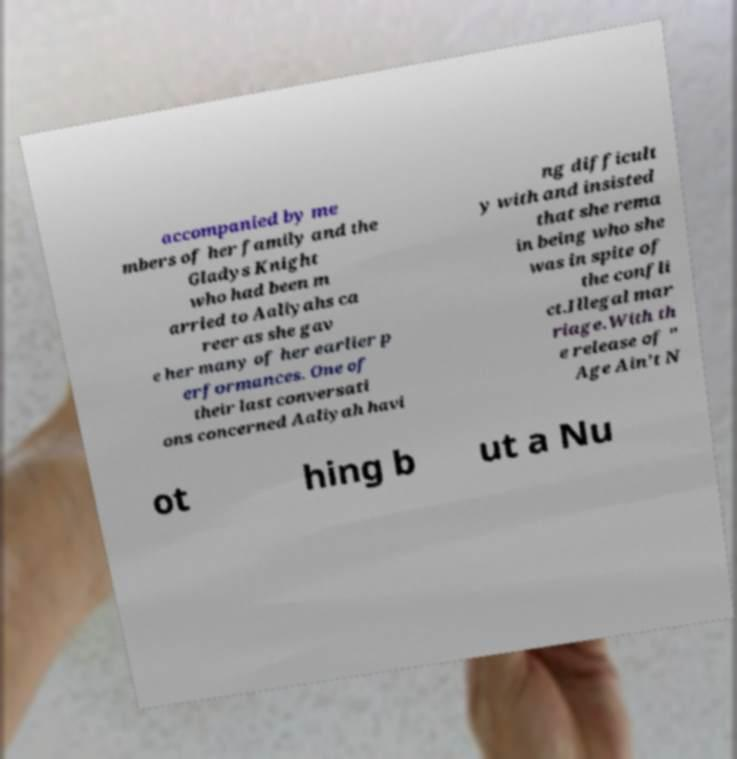Can you accurately transcribe the text from the provided image for me? accompanied by me mbers of her family and the Gladys Knight who had been m arried to Aaliyahs ca reer as she gav e her many of her earlier p erformances. One of their last conversati ons concerned Aaliyah havi ng difficult y with and insisted that she rema in being who she was in spite of the confli ct.Illegal mar riage.With th e release of " Age Ain't N ot hing b ut a Nu 